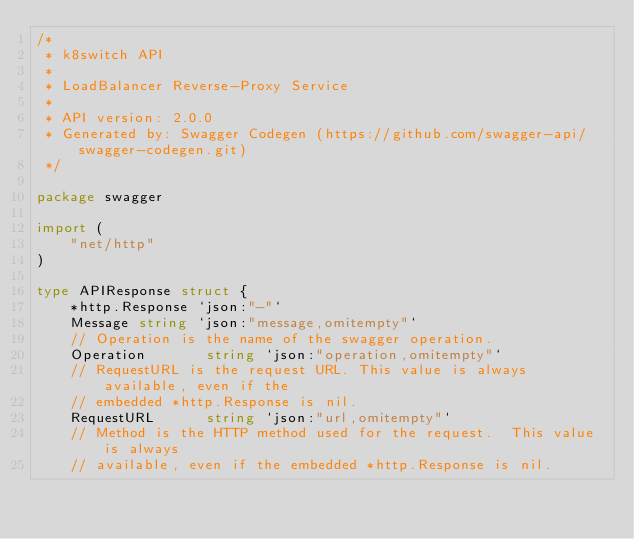<code> <loc_0><loc_0><loc_500><loc_500><_Go_>/*
 * k8switch API
 *
 * LoadBalancer Reverse-Proxy Service
 *
 * API version: 2.0.0
 * Generated by: Swagger Codegen (https://github.com/swagger-api/swagger-codegen.git)
 */

package swagger

import (
	"net/http"
)

type APIResponse struct {
	*http.Response `json:"-"`
	Message string `json:"message,omitempty"`
	// Operation is the name of the swagger operation.
	Operation       string `json:"operation,omitempty"`
	// RequestURL is the request URL. This value is always available, even if the
	// embedded *http.Response is nil.
	RequestURL      string `json:"url,omitempty"`
	// Method is the HTTP method used for the request.  This value is always
	// available, even if the embedded *http.Response is nil.</code> 